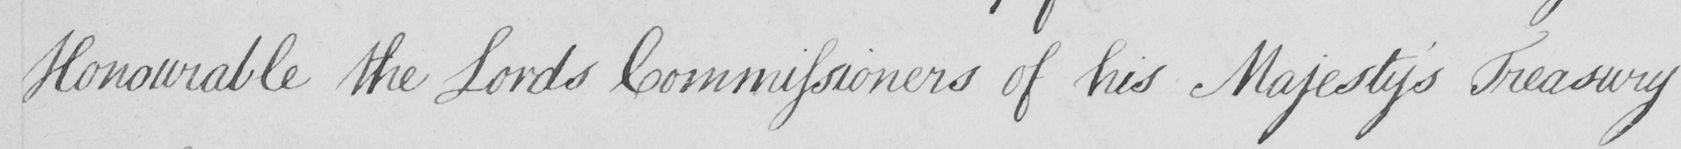Transcribe the text shown in this historical manuscript line. Honourable the Lords Commissioners of his Majesty ' s Treasury 